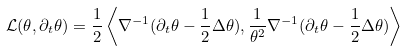Convert formula to latex. <formula><loc_0><loc_0><loc_500><loc_500>\mathcal { L } ( \theta , \partial _ { t } \theta ) = \frac { 1 } { 2 } \left \langle \nabla ^ { - 1 } ( \partial _ { t } \theta - \frac { 1 } { 2 } \Delta \theta ) , \frac { 1 } { \theta ^ { 2 } } \nabla ^ { - 1 } ( \partial _ { t } \theta - \frac { 1 } { 2 } \Delta \theta ) \right \rangle</formula> 